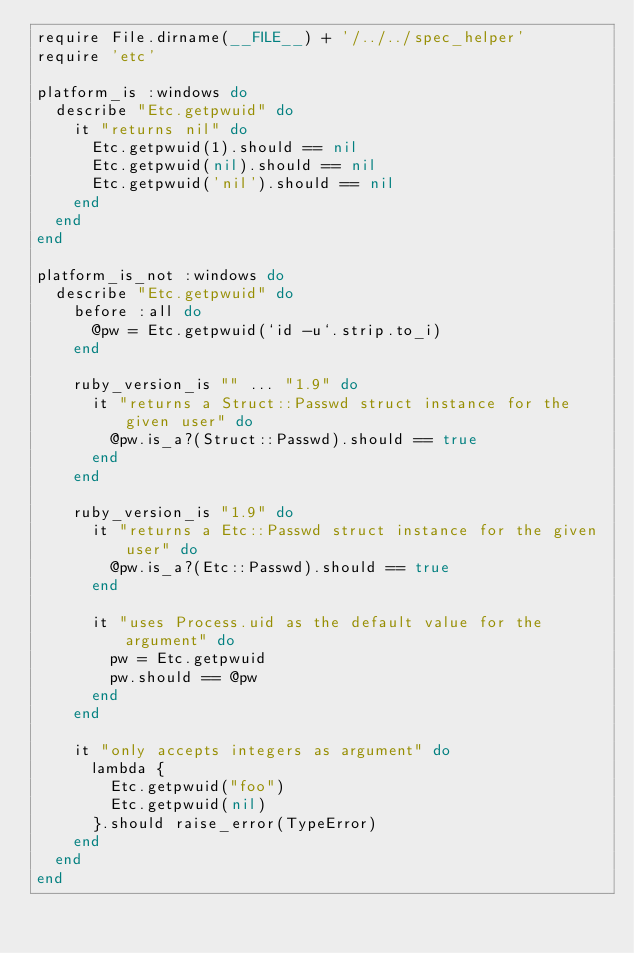<code> <loc_0><loc_0><loc_500><loc_500><_Ruby_>require File.dirname(__FILE__) + '/../../spec_helper'
require 'etc'

platform_is :windows do
  describe "Etc.getpwuid" do
    it "returns nil" do
      Etc.getpwuid(1).should == nil
      Etc.getpwuid(nil).should == nil
      Etc.getpwuid('nil').should == nil
    end
  end
end

platform_is_not :windows do
  describe "Etc.getpwuid" do
    before :all do
      @pw = Etc.getpwuid(`id -u`.strip.to_i)
    end

    ruby_version_is "" ... "1.9" do
      it "returns a Struct::Passwd struct instance for the given user" do
        @pw.is_a?(Struct::Passwd).should == true
      end
    end

    ruby_version_is "1.9" do
      it "returns a Etc::Passwd struct instance for the given user" do
        @pw.is_a?(Etc::Passwd).should == true
      end

      it "uses Process.uid as the default value for the argument" do
        pw = Etc.getpwuid
        pw.should == @pw
      end
    end

    it "only accepts integers as argument" do
      lambda {
        Etc.getpwuid("foo")
        Etc.getpwuid(nil)
      }.should raise_error(TypeError)
    end
  end
end
</code> 